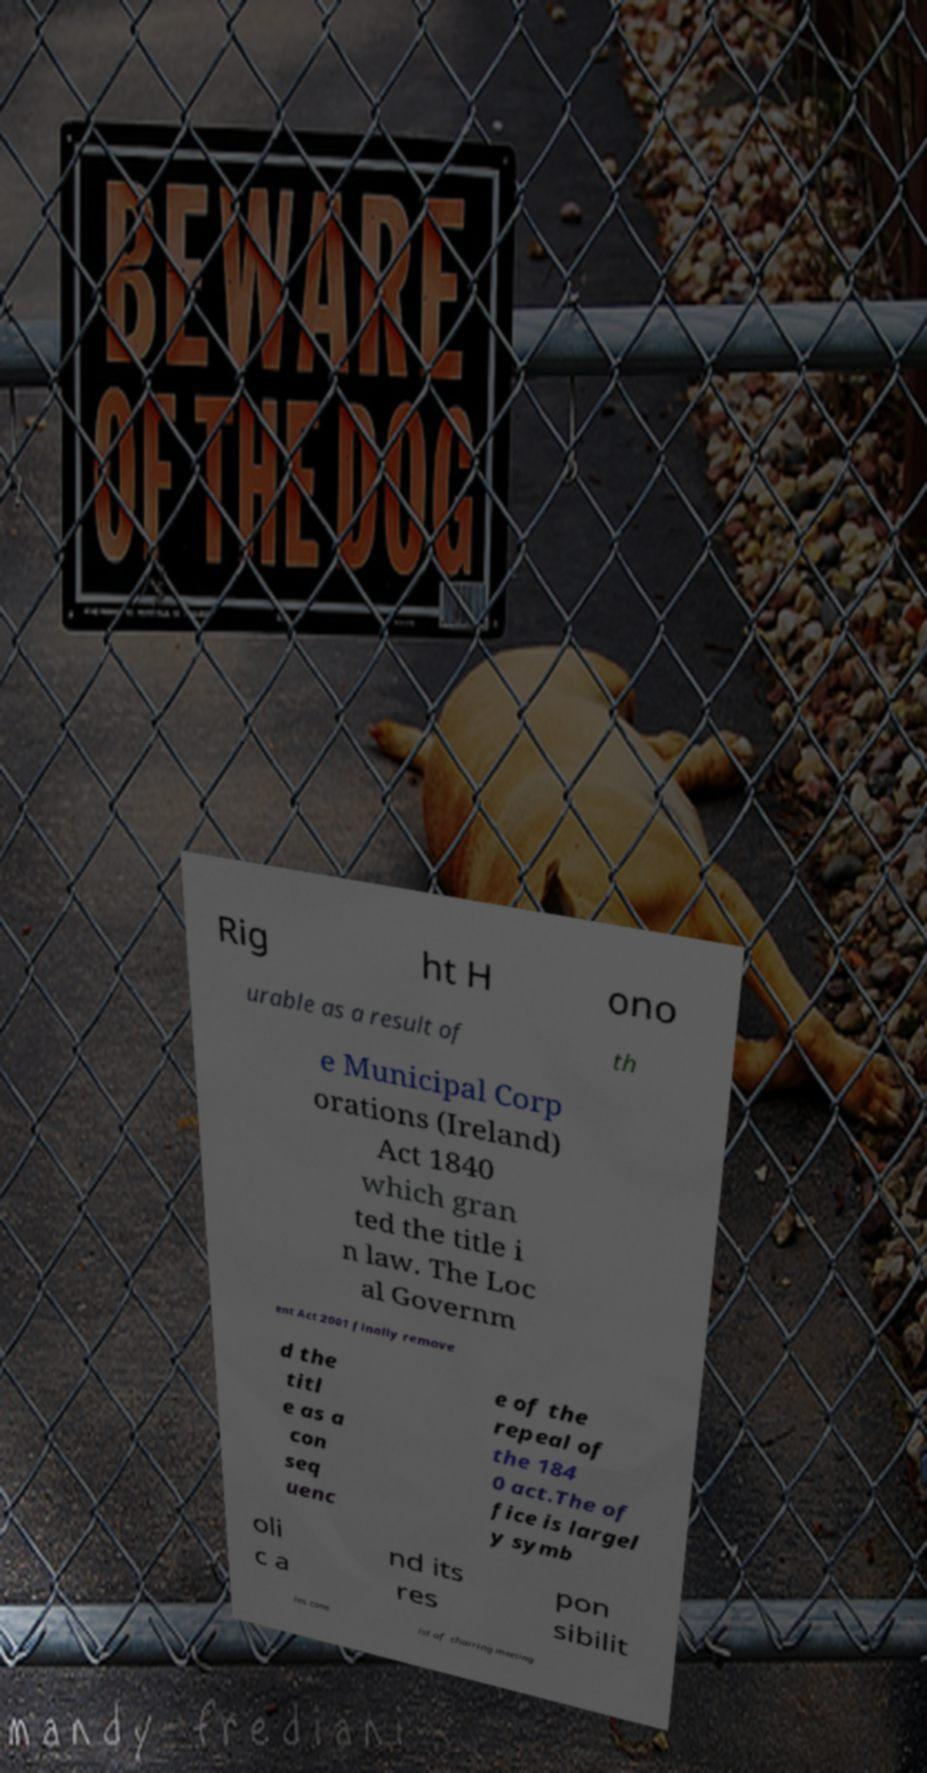Could you assist in decoding the text presented in this image and type it out clearly? Rig ht H ono urable as a result of th e Municipal Corp orations (Ireland) Act 1840 which gran ted the title i n law. The Loc al Governm ent Act 2001 finally remove d the titl e as a con seq uenc e of the repeal of the 184 0 act.The of fice is largel y symb oli c a nd its res pon sibilit ies cons ist of chairing meeting 